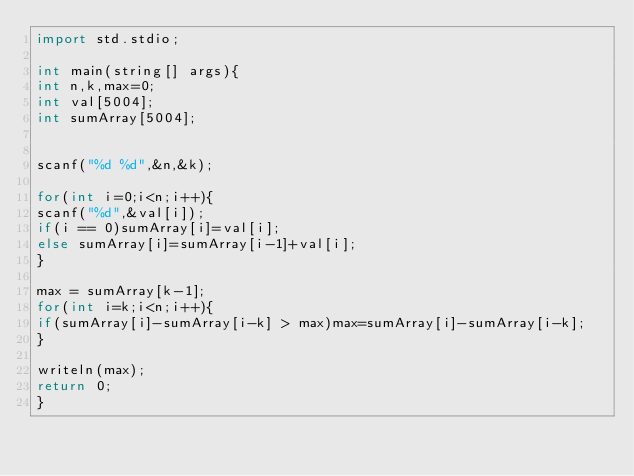Convert code to text. <code><loc_0><loc_0><loc_500><loc_500><_D_>import std.stdio;

int main(string[] args){
int n,k,max=0;
int val[5004];
int sumArray[5004];


scanf("%d %d",&n,&k);

for(int i=0;i<n;i++){
scanf("%d",&val[i]);
if(i == 0)sumArray[i]=val[i];
else sumArray[i]=sumArray[i-1]+val[i];
}

max = sumArray[k-1];
for(int i=k;i<n;i++){
if(sumArray[i]-sumArray[i-k] > max)max=sumArray[i]-sumArray[i-k];
}

writeln(max);
return 0;
}</code> 